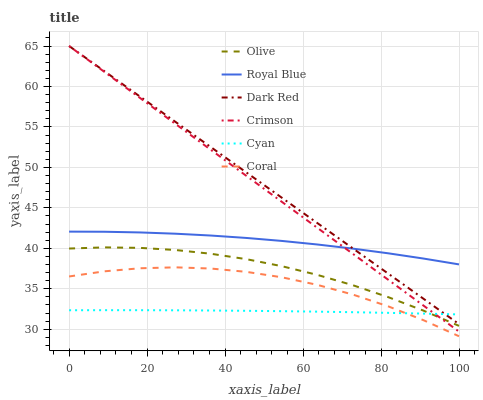Does Cyan have the minimum area under the curve?
Answer yes or no. Yes. Does Dark Red have the maximum area under the curve?
Answer yes or no. Yes. Does Coral have the minimum area under the curve?
Answer yes or no. No. Does Coral have the maximum area under the curve?
Answer yes or no. No. Is Crimson the smoothest?
Answer yes or no. Yes. Is Coral the roughest?
Answer yes or no. Yes. Is Royal Blue the smoothest?
Answer yes or no. No. Is Royal Blue the roughest?
Answer yes or no. No. Does Coral have the lowest value?
Answer yes or no. Yes. Does Royal Blue have the lowest value?
Answer yes or no. No. Does Crimson have the highest value?
Answer yes or no. Yes. Does Coral have the highest value?
Answer yes or no. No. Is Olive less than Royal Blue?
Answer yes or no. Yes. Is Royal Blue greater than Coral?
Answer yes or no. Yes. Does Coral intersect Cyan?
Answer yes or no. Yes. Is Coral less than Cyan?
Answer yes or no. No. Is Coral greater than Cyan?
Answer yes or no. No. Does Olive intersect Royal Blue?
Answer yes or no. No. 